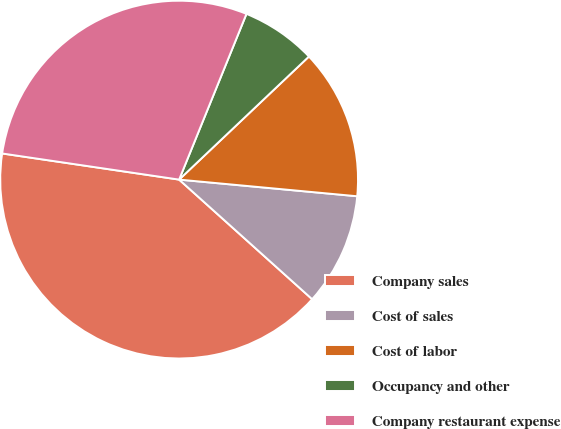Convert chart. <chart><loc_0><loc_0><loc_500><loc_500><pie_chart><fcel>Company sales<fcel>Cost of sales<fcel>Cost of labor<fcel>Occupancy and other<fcel>Company restaurant expense<nl><fcel>40.68%<fcel>10.17%<fcel>13.56%<fcel>6.78%<fcel>28.81%<nl></chart> 